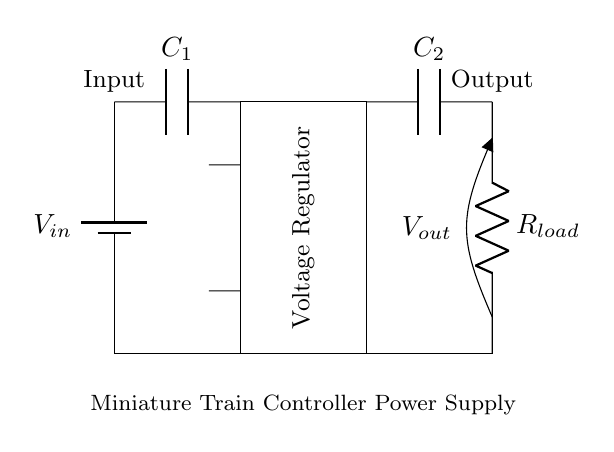What is the input component in this circuit? The input component is a battery designated as V_in, providing the initial voltage supply for the circuit.
Answer: battery What type of component is C1? C1 is a capacitor, which in this context helps filter and stabilize the voltage supplied by the input before it reaches the voltage regulator.
Answer: capacitor What is the purpose of the voltage regulator? The voltage regulator's role is to ensure that the output voltage remains constant, despite variations in input voltage or load current, providing a steady power supply to the miniature train controller.
Answer: regulates voltage What type of load does this circuit power? The load in this circuit is represented by R_load, which in the context of a miniature train controller would typically be the electrical load required to operate the train's motor and other components.
Answer: resistor What are the two capacitors in the circuit? The two capacitors are C1, which is at the input side near the battery, and C2, which is at the output side near the load resistor. They serve to filter and smooth the voltage.
Answer: C1 and C2 How does the output voltage relate to the input voltage? The output voltage V_out is typically lower than the input voltage V_in after being regulated by the voltage regulator, which adjusts it to the required level for the load.
Answer: lower What is the significance of the ground connection? The ground connection is crucial as it provides a common return path for current, ensuring that the circuit functions correctly and safely by referencing all voltages to a single point.
Answer: reference point 